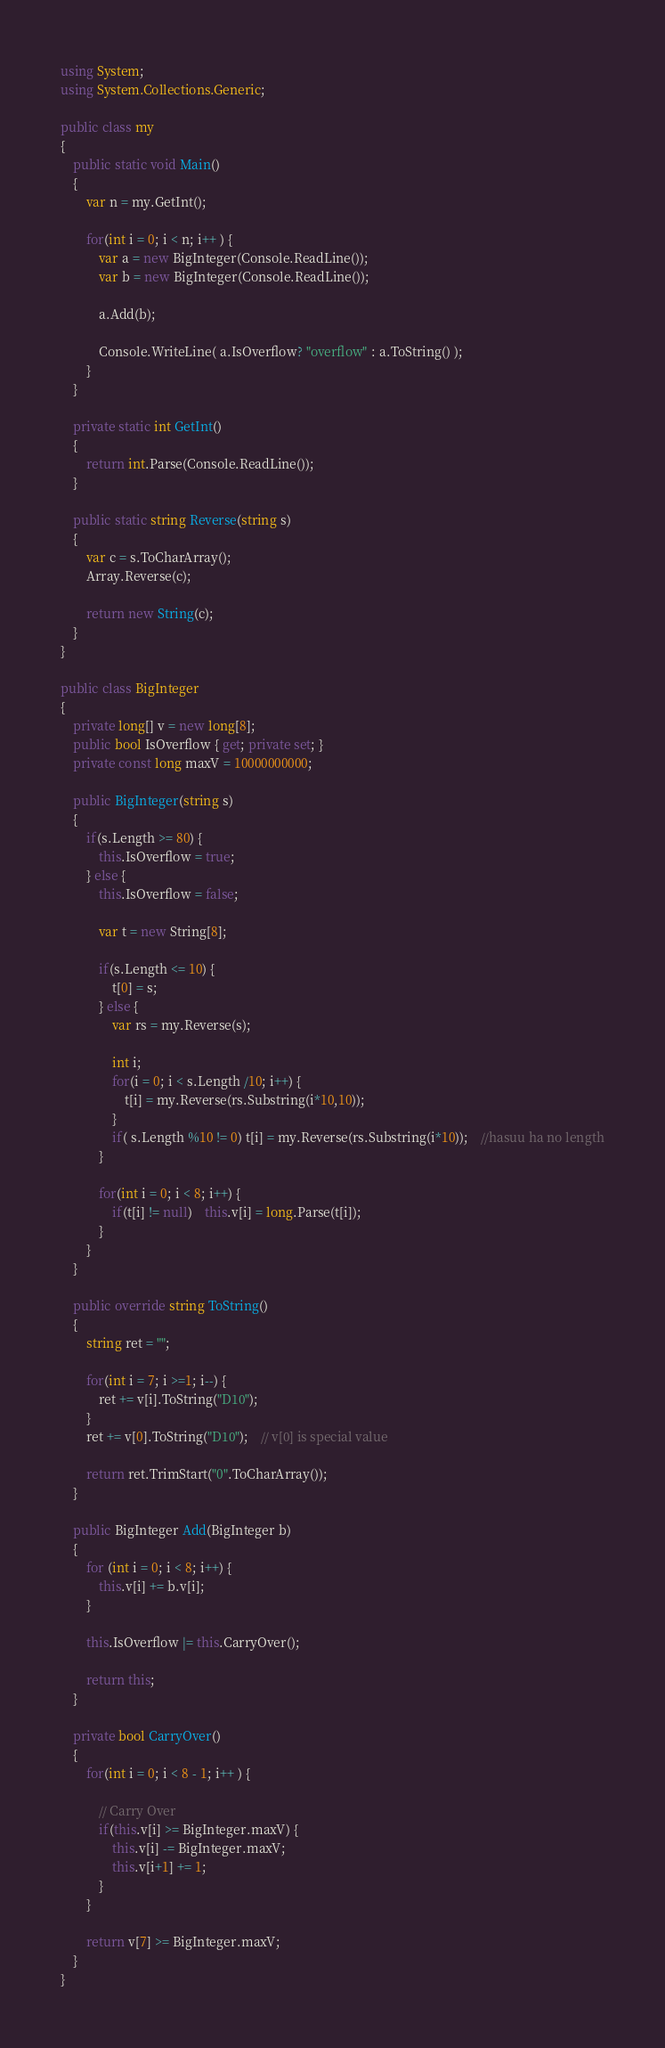Convert code to text. <code><loc_0><loc_0><loc_500><loc_500><_C#_>using System;
using System.Collections.Generic;
					
public class my
{
	public static void Main()
	{
		var n = my.GetInt();
		
		for(int i = 0; i < n; i++ ) {
			var a = new BigInteger(Console.ReadLine());
			var b = new BigInteger(Console.ReadLine());
 
			a.Add(b);
 
			Console.WriteLine( a.IsOverflow? "overflow" : a.ToString() );
		}
	}
	
	private static int GetInt()
	{
		return int.Parse(Console.ReadLine());
	}
	
	public static string Reverse(string s)
	{
		var c = s.ToCharArray();
		Array.Reverse(c);
		
		return new String(c);
	}
}

public class BigInteger
{
	private long[] v = new long[8];
	public bool IsOverflow { get; private set; }
	private const long maxV = 10000000000;
	
	public BigInteger(string s)
	{
		if(s.Length >= 80) {
			this.IsOverflow = true;
		} else {
			this.IsOverflow = false;
			
			var t = new String[8];
			
			if(s.Length <= 10) {
				t[0] = s;
			} else {
				var rs = my.Reverse(s);
				
				int i;
				for(i = 0; i < s.Length /10; i++) {
					t[i] = my.Reverse(rs.Substring(i*10,10));
				}
				if( s.Length %10 != 0) t[i] = my.Reverse(rs.Substring(i*10));	//hasuu ha no length
			}
			
			for(int i = 0; i < 8; i++) {
				if(t[i] != null)	this.v[i] = long.Parse(t[i]);
			}
		}
	}
	
	public override string ToString()
	{
		string ret = "";
		
		for(int i = 7; i >=1; i--) {
			ret += v[i].ToString("D10");
		}
		ret += v[0].ToString("D10");	// v[0] is special value
		
		return ret.TrimStart("0".ToCharArray());
	}
	
	public BigInteger Add(BigInteger b)
	{
		for (int i = 0; i < 8; i++) {
			this.v[i] += b.v[i];
		}
		
		this.IsOverflow |= this.CarryOver();
		
		return this;
	}
	
	private bool CarryOver()
	{
		for(int i = 0; i < 8 - 1; i++ ) {
			
			// Carry Over
			if(this.v[i] >= BigInteger.maxV) {
				this.v[i] -= BigInteger.maxV;
				this.v[i+1] += 1;
			}
		}
		
		return v[7] >= BigInteger.maxV;
	}
}</code> 